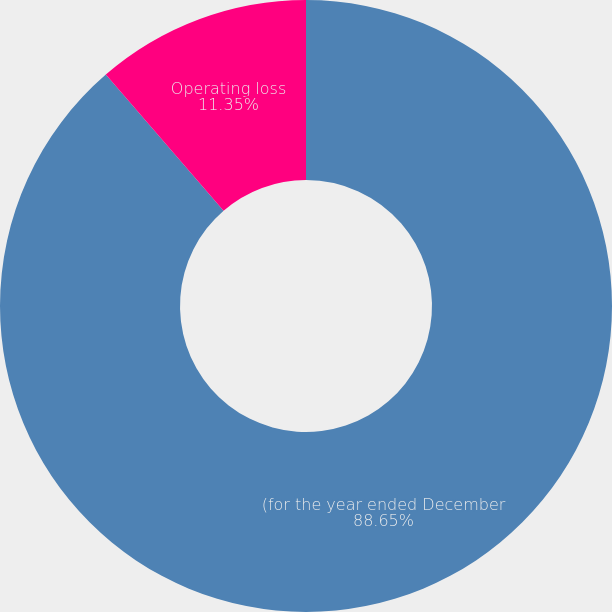<chart> <loc_0><loc_0><loc_500><loc_500><pie_chart><fcel>(for the year ended December<fcel>Operating loss<nl><fcel>88.65%<fcel>11.35%<nl></chart> 